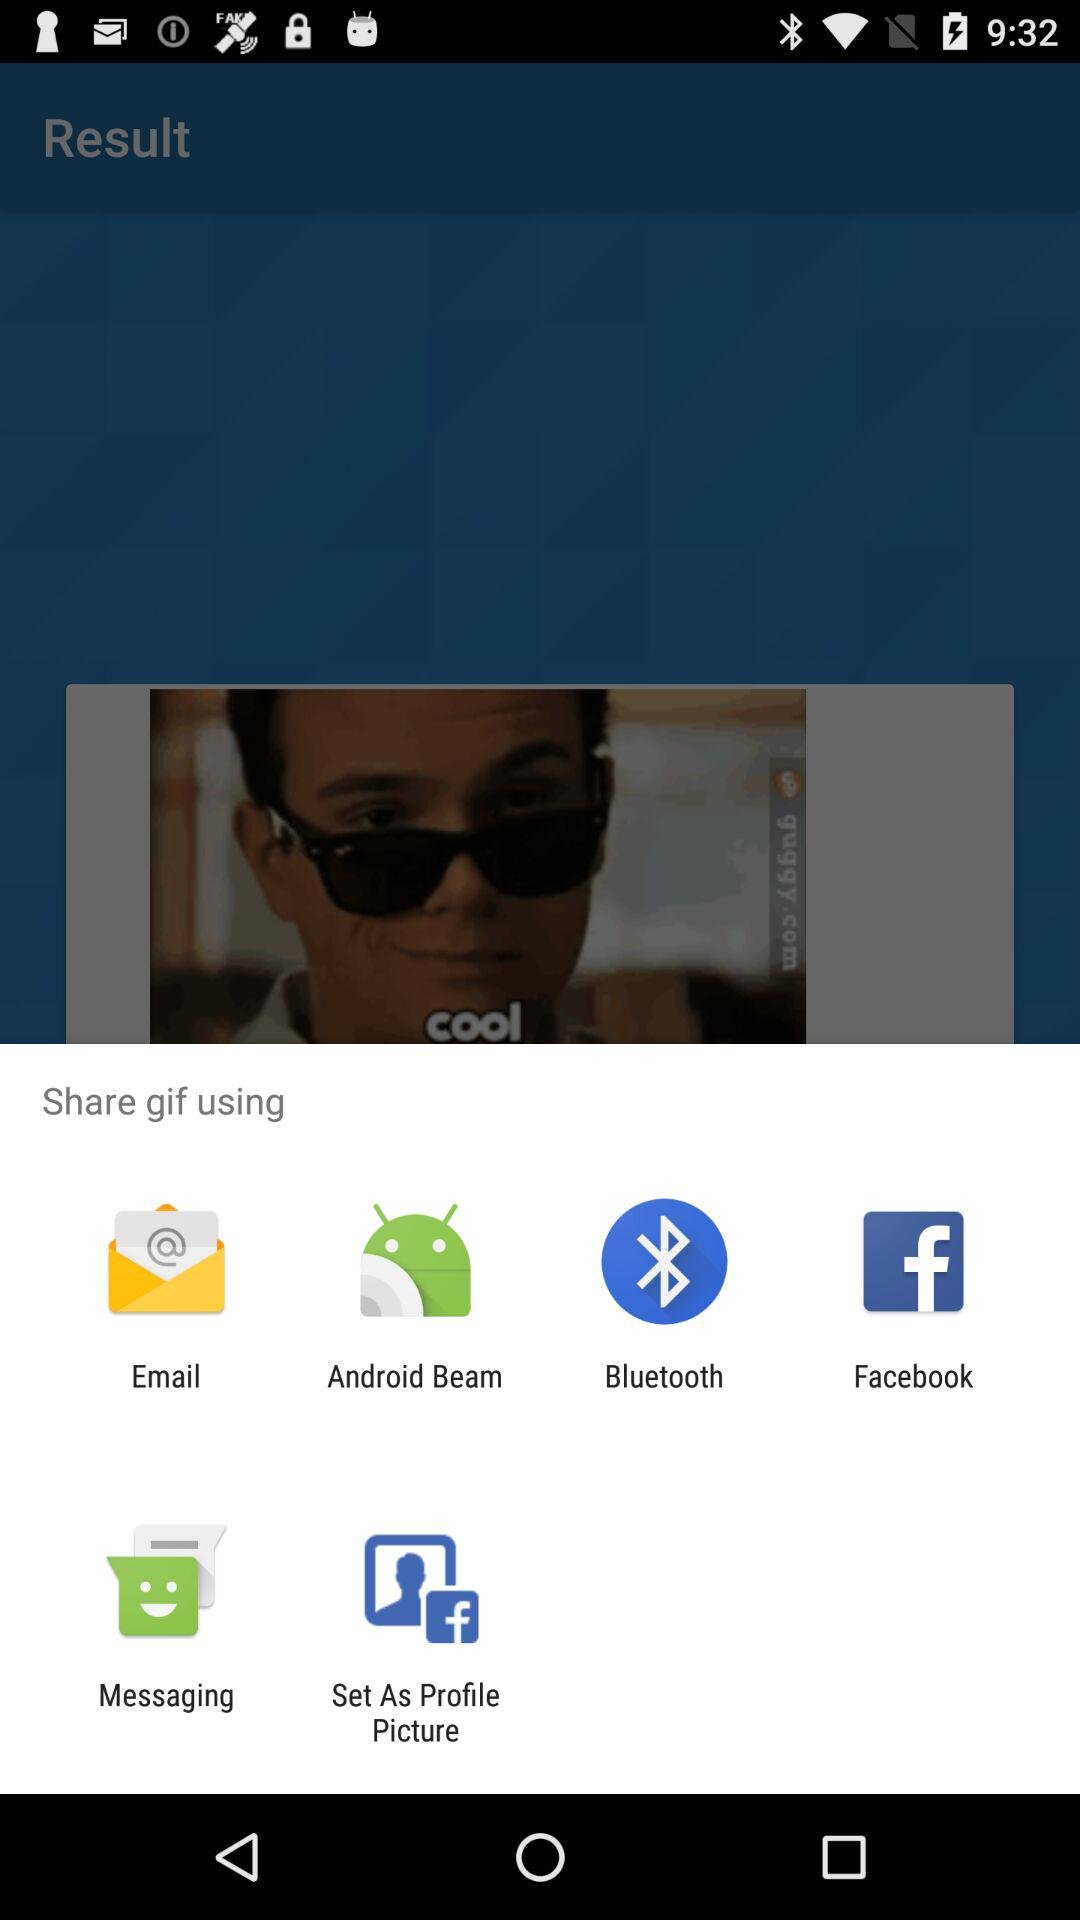What are the alternative gif sharing applications? The sharing applications are "Email", "Android Beam", "Bluetooth", "Facebook", "Messaging", and "Set As Profile Picture". 